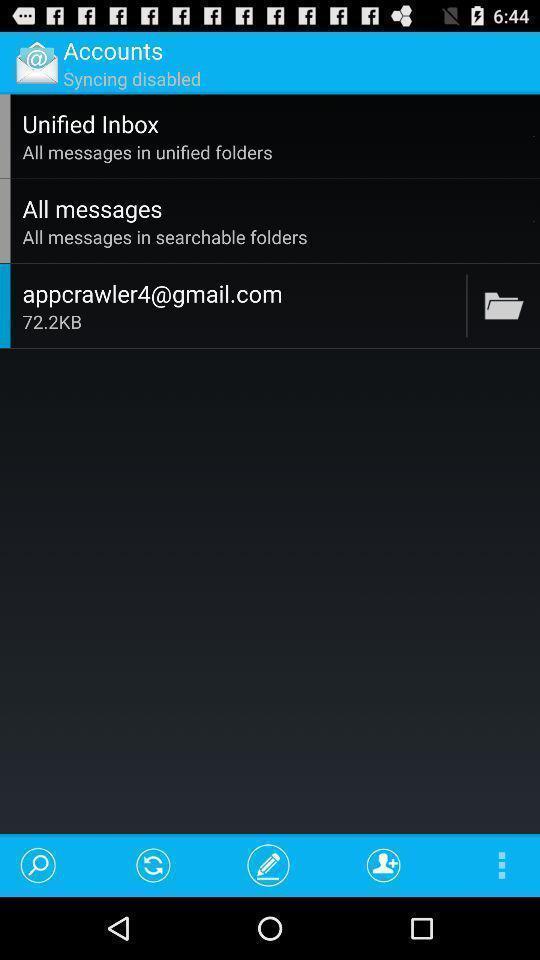Summarize the main components in this picture. Page showing options for an email client app. 